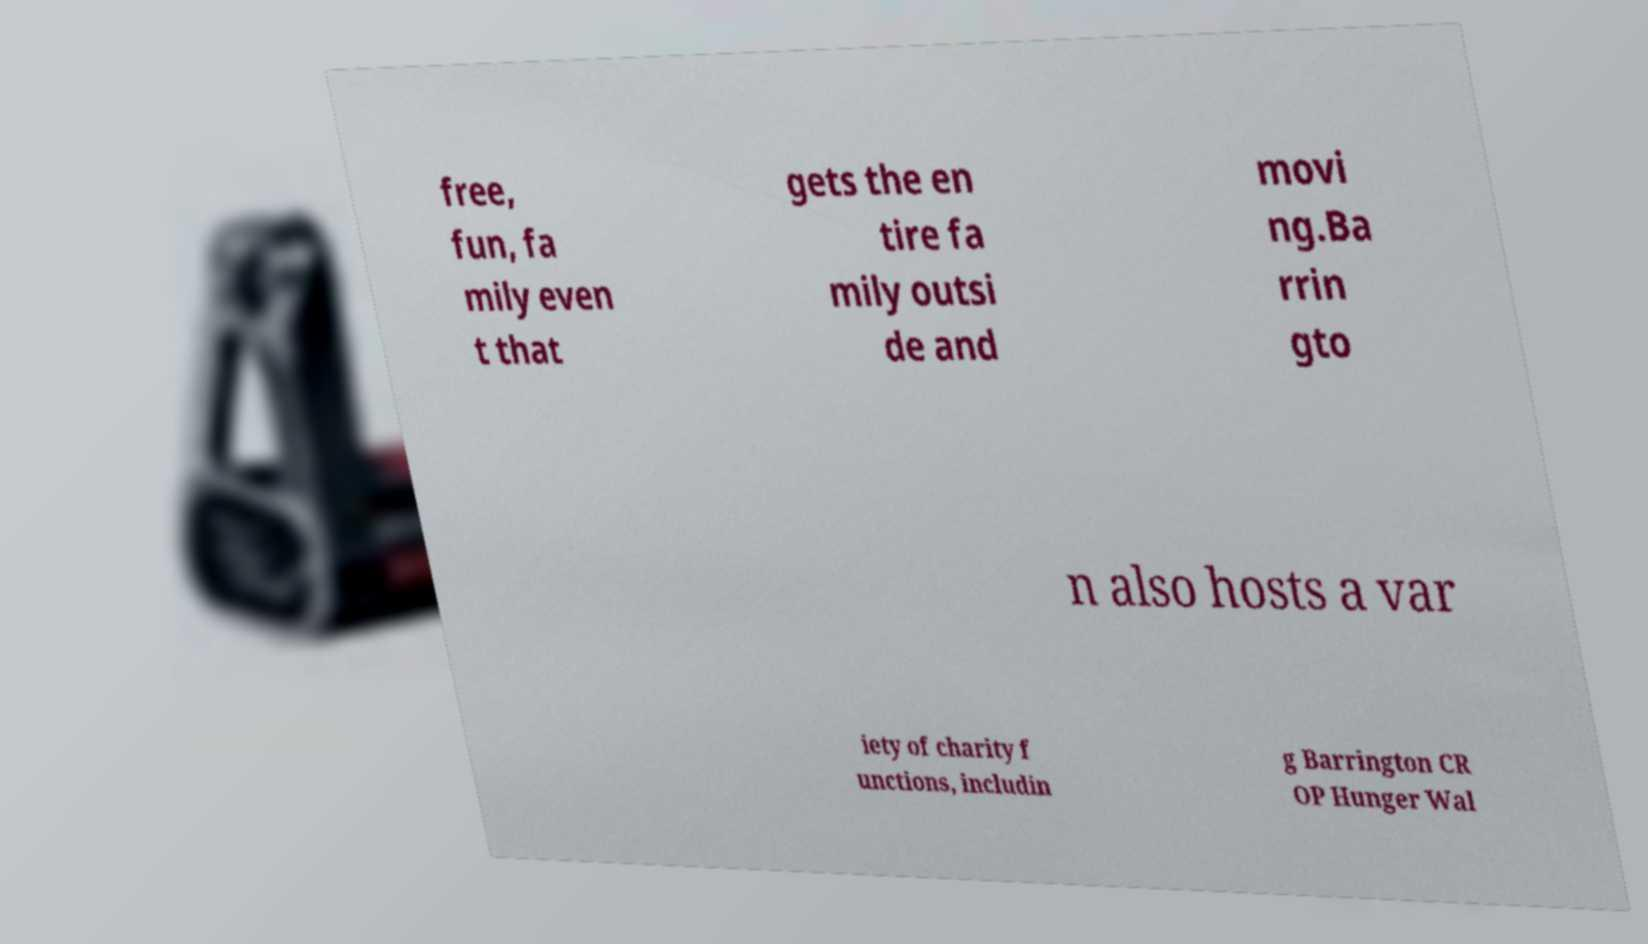Can you read and provide the text displayed in the image?This photo seems to have some interesting text. Can you extract and type it out for me? free, fun, fa mily even t that gets the en tire fa mily outsi de and movi ng.Ba rrin gto n also hosts a var iety of charity f unctions, includin g Barrington CR OP Hunger Wal 